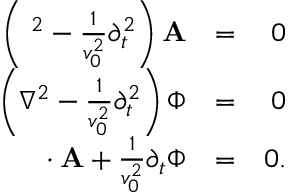Convert formula to latex. <formula><loc_0><loc_0><loc_500><loc_500>\begin{array} { r l r } { \left ( { \nabla } ^ { 2 } - \frac { 1 } { v _ { 0 } ^ { 2 } } \partial _ { t } ^ { 2 } \right ) { A } } & { = } & { 0 } \\ { \left ( \nabla ^ { 2 } - \frac { 1 } { v _ { 0 } ^ { 2 } } \partial _ { t } ^ { 2 } \right ) \Phi } & { = } & { 0 } \\ { { \nabla } \cdot { A } + \frac { 1 } { v _ { 0 } ^ { 2 } } \partial _ { t } \Phi } & { = } & { 0 . } \end{array}</formula> 